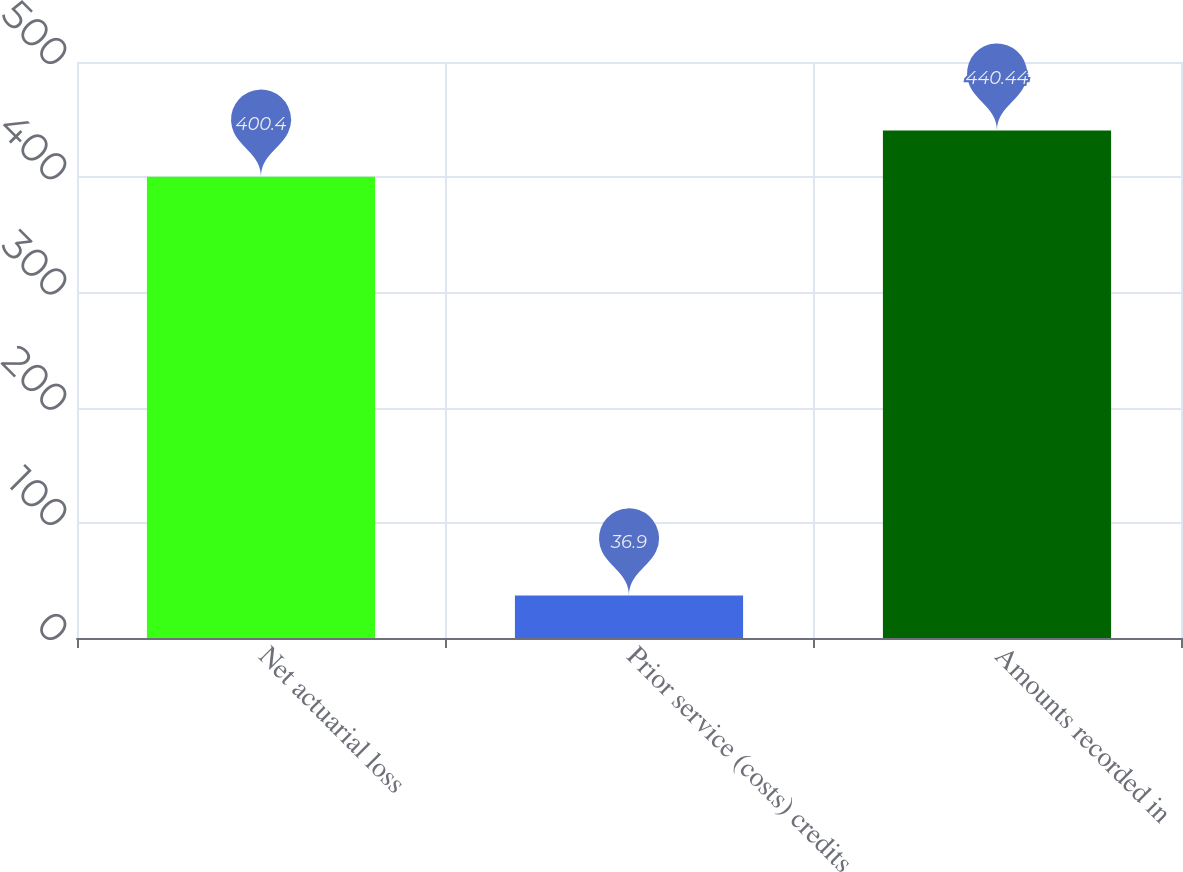Convert chart to OTSL. <chart><loc_0><loc_0><loc_500><loc_500><bar_chart><fcel>Net actuarial loss<fcel>Prior service (costs) credits<fcel>Amounts recorded in<nl><fcel>400.4<fcel>36.9<fcel>440.44<nl></chart> 